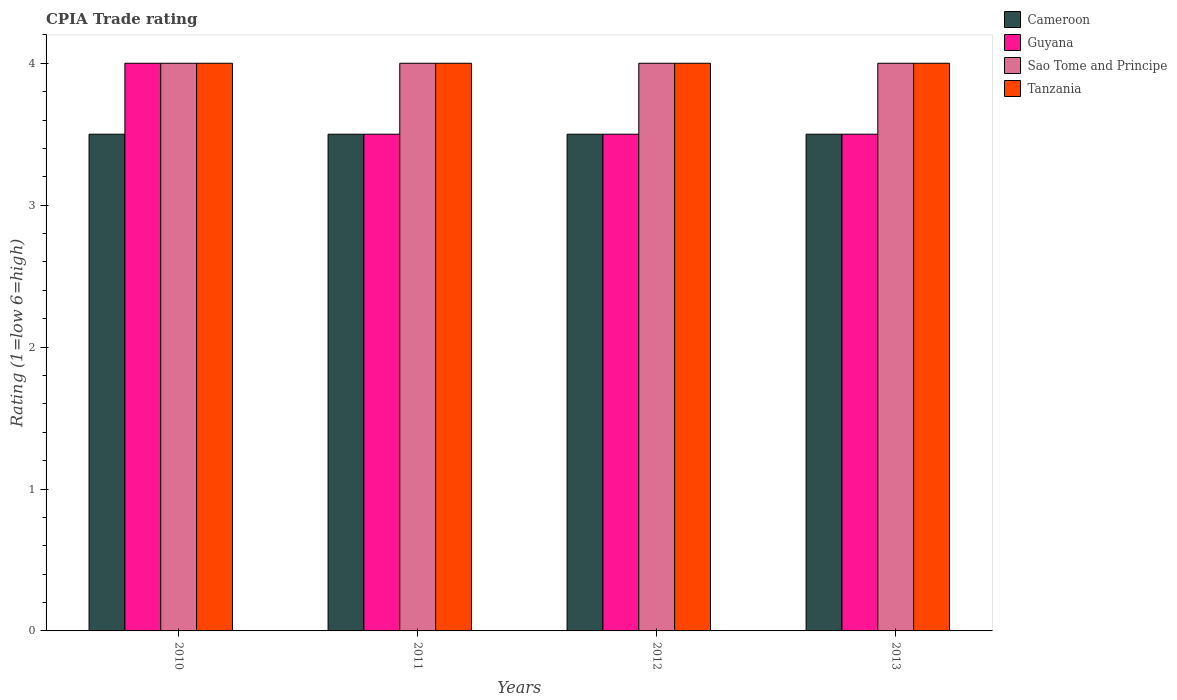How many groups of bars are there?
Your answer should be very brief. 4. Are the number of bars on each tick of the X-axis equal?
Make the answer very short. Yes. How many bars are there on the 2nd tick from the left?
Your answer should be very brief. 4. In how many cases, is the number of bars for a given year not equal to the number of legend labels?
Offer a terse response. 0. What is the CPIA rating in Sao Tome and Principe in 2013?
Give a very brief answer. 4. Across all years, what is the maximum CPIA rating in Cameroon?
Your answer should be compact. 3.5. What is the average CPIA rating in Tanzania per year?
Ensure brevity in your answer.  4. In how many years, is the CPIA rating in Cameroon greater than 0.6000000000000001?
Provide a short and direct response. 4. Is the difference between the CPIA rating in Sao Tome and Principe in 2011 and 2013 greater than the difference between the CPIA rating in Cameroon in 2011 and 2013?
Your response must be concise. No. In how many years, is the CPIA rating in Guyana greater than the average CPIA rating in Guyana taken over all years?
Offer a very short reply. 1. Is it the case that in every year, the sum of the CPIA rating in Guyana and CPIA rating in Sao Tome and Principe is greater than the sum of CPIA rating in Cameroon and CPIA rating in Tanzania?
Your answer should be very brief. Yes. What does the 2nd bar from the left in 2011 represents?
Your answer should be very brief. Guyana. What does the 3rd bar from the right in 2012 represents?
Offer a terse response. Guyana. Are all the bars in the graph horizontal?
Offer a very short reply. No. What is the difference between two consecutive major ticks on the Y-axis?
Offer a terse response. 1. Are the values on the major ticks of Y-axis written in scientific E-notation?
Provide a short and direct response. No. What is the title of the graph?
Ensure brevity in your answer.  CPIA Trade rating. Does "Tuvalu" appear as one of the legend labels in the graph?
Your answer should be compact. No. What is the label or title of the X-axis?
Offer a terse response. Years. What is the Rating (1=low 6=high) in Sao Tome and Principe in 2010?
Make the answer very short. 4. What is the Rating (1=low 6=high) of Tanzania in 2010?
Make the answer very short. 4. What is the Rating (1=low 6=high) of Guyana in 2011?
Provide a short and direct response. 3.5. What is the Rating (1=low 6=high) in Sao Tome and Principe in 2011?
Offer a terse response. 4. What is the Rating (1=low 6=high) in Tanzania in 2011?
Keep it short and to the point. 4. What is the Rating (1=low 6=high) of Cameroon in 2012?
Keep it short and to the point. 3.5. What is the Rating (1=low 6=high) in Guyana in 2012?
Make the answer very short. 3.5. What is the Rating (1=low 6=high) of Sao Tome and Principe in 2012?
Your answer should be very brief. 4. Across all years, what is the maximum Rating (1=low 6=high) in Cameroon?
Provide a short and direct response. 3.5. Across all years, what is the maximum Rating (1=low 6=high) in Guyana?
Your response must be concise. 4. Across all years, what is the minimum Rating (1=low 6=high) of Guyana?
Your answer should be compact. 3.5. Across all years, what is the minimum Rating (1=low 6=high) of Sao Tome and Principe?
Offer a very short reply. 4. What is the total Rating (1=low 6=high) in Cameroon in the graph?
Give a very brief answer. 14. What is the total Rating (1=low 6=high) in Sao Tome and Principe in the graph?
Keep it short and to the point. 16. What is the difference between the Rating (1=low 6=high) of Guyana in 2010 and that in 2011?
Ensure brevity in your answer.  0.5. What is the difference between the Rating (1=low 6=high) in Cameroon in 2010 and that in 2012?
Make the answer very short. 0. What is the difference between the Rating (1=low 6=high) in Cameroon in 2010 and that in 2013?
Your response must be concise. 0. What is the difference between the Rating (1=low 6=high) in Cameroon in 2011 and that in 2013?
Give a very brief answer. 0. What is the difference between the Rating (1=low 6=high) in Sao Tome and Principe in 2011 and that in 2013?
Give a very brief answer. 0. What is the difference between the Rating (1=low 6=high) in Tanzania in 2011 and that in 2013?
Ensure brevity in your answer.  0. What is the difference between the Rating (1=low 6=high) of Tanzania in 2012 and that in 2013?
Provide a succinct answer. 0. What is the difference between the Rating (1=low 6=high) of Cameroon in 2010 and the Rating (1=low 6=high) of Tanzania in 2011?
Keep it short and to the point. -0.5. What is the difference between the Rating (1=low 6=high) of Guyana in 2010 and the Rating (1=low 6=high) of Sao Tome and Principe in 2011?
Give a very brief answer. 0. What is the difference between the Rating (1=low 6=high) in Guyana in 2010 and the Rating (1=low 6=high) in Tanzania in 2011?
Your answer should be compact. 0. What is the difference between the Rating (1=low 6=high) of Sao Tome and Principe in 2010 and the Rating (1=low 6=high) of Tanzania in 2011?
Give a very brief answer. 0. What is the difference between the Rating (1=low 6=high) in Cameroon in 2010 and the Rating (1=low 6=high) in Sao Tome and Principe in 2012?
Offer a very short reply. -0.5. What is the difference between the Rating (1=low 6=high) in Guyana in 2010 and the Rating (1=low 6=high) in Tanzania in 2012?
Keep it short and to the point. 0. What is the difference between the Rating (1=low 6=high) of Cameroon in 2010 and the Rating (1=low 6=high) of Sao Tome and Principe in 2013?
Make the answer very short. -0.5. What is the difference between the Rating (1=low 6=high) of Guyana in 2010 and the Rating (1=low 6=high) of Sao Tome and Principe in 2013?
Give a very brief answer. 0. What is the difference between the Rating (1=low 6=high) of Sao Tome and Principe in 2010 and the Rating (1=low 6=high) of Tanzania in 2013?
Keep it short and to the point. 0. What is the difference between the Rating (1=low 6=high) of Cameroon in 2011 and the Rating (1=low 6=high) of Guyana in 2012?
Your response must be concise. 0. What is the difference between the Rating (1=low 6=high) of Cameroon in 2011 and the Rating (1=low 6=high) of Sao Tome and Principe in 2012?
Ensure brevity in your answer.  -0.5. What is the difference between the Rating (1=low 6=high) of Guyana in 2011 and the Rating (1=low 6=high) of Tanzania in 2012?
Offer a terse response. -0.5. What is the difference between the Rating (1=low 6=high) of Cameroon in 2011 and the Rating (1=low 6=high) of Sao Tome and Principe in 2013?
Offer a terse response. -0.5. What is the difference between the Rating (1=low 6=high) of Cameroon in 2011 and the Rating (1=low 6=high) of Tanzania in 2013?
Keep it short and to the point. -0.5. What is the difference between the Rating (1=low 6=high) of Guyana in 2011 and the Rating (1=low 6=high) of Sao Tome and Principe in 2013?
Provide a short and direct response. -0.5. What is the difference between the Rating (1=low 6=high) in Cameroon in 2012 and the Rating (1=low 6=high) in Sao Tome and Principe in 2013?
Your response must be concise. -0.5. What is the difference between the Rating (1=low 6=high) of Cameroon in 2012 and the Rating (1=low 6=high) of Tanzania in 2013?
Give a very brief answer. -0.5. What is the average Rating (1=low 6=high) in Guyana per year?
Your answer should be compact. 3.62. What is the average Rating (1=low 6=high) of Sao Tome and Principe per year?
Your answer should be compact. 4. What is the average Rating (1=low 6=high) of Tanzania per year?
Make the answer very short. 4. In the year 2010, what is the difference between the Rating (1=low 6=high) of Cameroon and Rating (1=low 6=high) of Guyana?
Provide a succinct answer. -0.5. In the year 2010, what is the difference between the Rating (1=low 6=high) of Cameroon and Rating (1=low 6=high) of Sao Tome and Principe?
Keep it short and to the point. -0.5. In the year 2010, what is the difference between the Rating (1=low 6=high) in Sao Tome and Principe and Rating (1=low 6=high) in Tanzania?
Keep it short and to the point. 0. In the year 2011, what is the difference between the Rating (1=low 6=high) of Cameroon and Rating (1=low 6=high) of Guyana?
Provide a short and direct response. 0. In the year 2011, what is the difference between the Rating (1=low 6=high) in Cameroon and Rating (1=low 6=high) in Sao Tome and Principe?
Make the answer very short. -0.5. In the year 2011, what is the difference between the Rating (1=low 6=high) in Sao Tome and Principe and Rating (1=low 6=high) in Tanzania?
Provide a short and direct response. 0. In the year 2012, what is the difference between the Rating (1=low 6=high) of Cameroon and Rating (1=low 6=high) of Guyana?
Your response must be concise. 0. In the year 2012, what is the difference between the Rating (1=low 6=high) of Cameroon and Rating (1=low 6=high) of Tanzania?
Your answer should be very brief. -0.5. In the year 2012, what is the difference between the Rating (1=low 6=high) of Guyana and Rating (1=low 6=high) of Sao Tome and Principe?
Your answer should be very brief. -0.5. In the year 2012, what is the difference between the Rating (1=low 6=high) in Guyana and Rating (1=low 6=high) in Tanzania?
Offer a very short reply. -0.5. In the year 2013, what is the difference between the Rating (1=low 6=high) of Cameroon and Rating (1=low 6=high) of Guyana?
Make the answer very short. 0. In the year 2013, what is the difference between the Rating (1=low 6=high) in Guyana and Rating (1=low 6=high) in Sao Tome and Principe?
Keep it short and to the point. -0.5. What is the ratio of the Rating (1=low 6=high) in Guyana in 2010 to that in 2011?
Keep it short and to the point. 1.14. What is the ratio of the Rating (1=low 6=high) in Sao Tome and Principe in 2010 to that in 2011?
Offer a very short reply. 1. What is the ratio of the Rating (1=low 6=high) of Cameroon in 2010 to that in 2012?
Your response must be concise. 1. What is the ratio of the Rating (1=low 6=high) of Sao Tome and Principe in 2010 to that in 2012?
Make the answer very short. 1. What is the ratio of the Rating (1=low 6=high) in Tanzania in 2010 to that in 2012?
Provide a succinct answer. 1. What is the ratio of the Rating (1=low 6=high) of Sao Tome and Principe in 2010 to that in 2013?
Provide a short and direct response. 1. What is the ratio of the Rating (1=low 6=high) in Tanzania in 2010 to that in 2013?
Provide a short and direct response. 1. What is the ratio of the Rating (1=low 6=high) in Sao Tome and Principe in 2011 to that in 2012?
Give a very brief answer. 1. What is the ratio of the Rating (1=low 6=high) in Tanzania in 2011 to that in 2012?
Make the answer very short. 1. What is the ratio of the Rating (1=low 6=high) of Cameroon in 2011 to that in 2013?
Keep it short and to the point. 1. What is the ratio of the Rating (1=low 6=high) of Guyana in 2011 to that in 2013?
Your answer should be very brief. 1. What is the ratio of the Rating (1=low 6=high) in Tanzania in 2011 to that in 2013?
Offer a very short reply. 1. What is the ratio of the Rating (1=low 6=high) of Sao Tome and Principe in 2012 to that in 2013?
Your response must be concise. 1. What is the difference between the highest and the lowest Rating (1=low 6=high) of Guyana?
Keep it short and to the point. 0.5. 